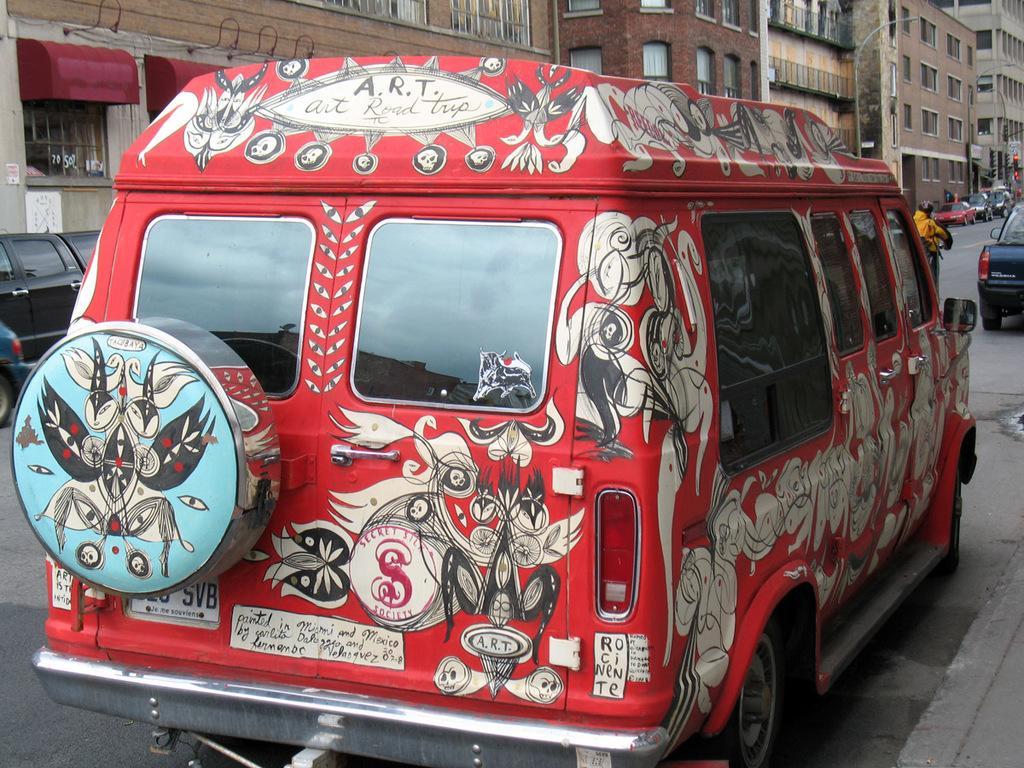Could you give a brief overview of what you see in this image? This is an outside view. Here I can see a red color vehicle on which there are few paintings. In the background there are some more vehicles on the road and also I can see few buildings. 